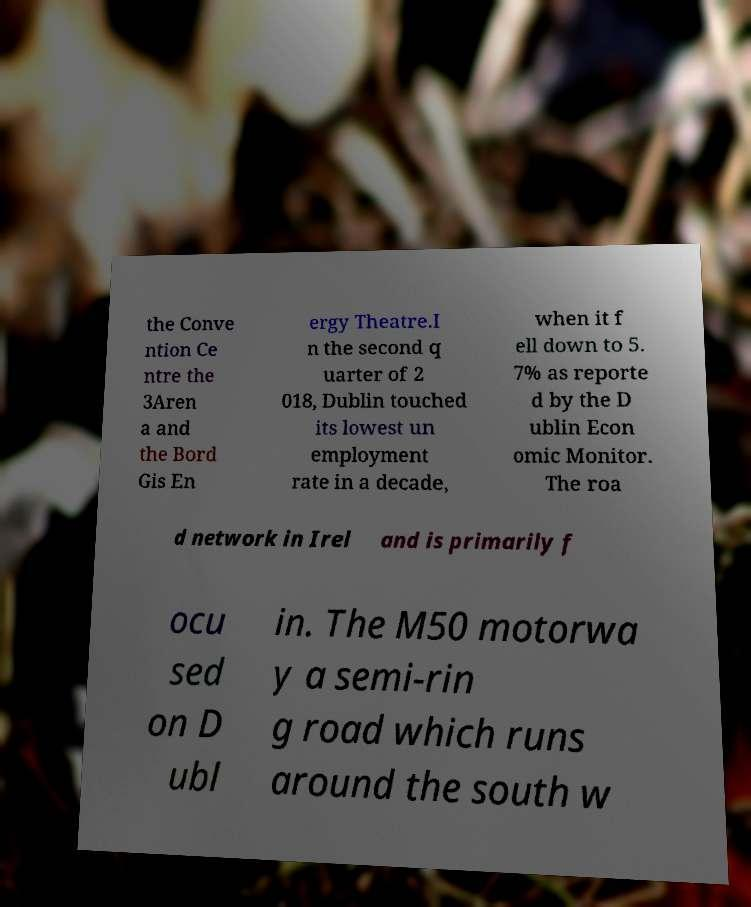Can you accurately transcribe the text from the provided image for me? the Conve ntion Ce ntre the 3Aren a and the Bord Gis En ergy Theatre.I n the second q uarter of 2 018, Dublin touched its lowest un employment rate in a decade, when it f ell down to 5. 7% as reporte d by the D ublin Econ omic Monitor. The roa d network in Irel and is primarily f ocu sed on D ubl in. The M50 motorwa y a semi-rin g road which runs around the south w 